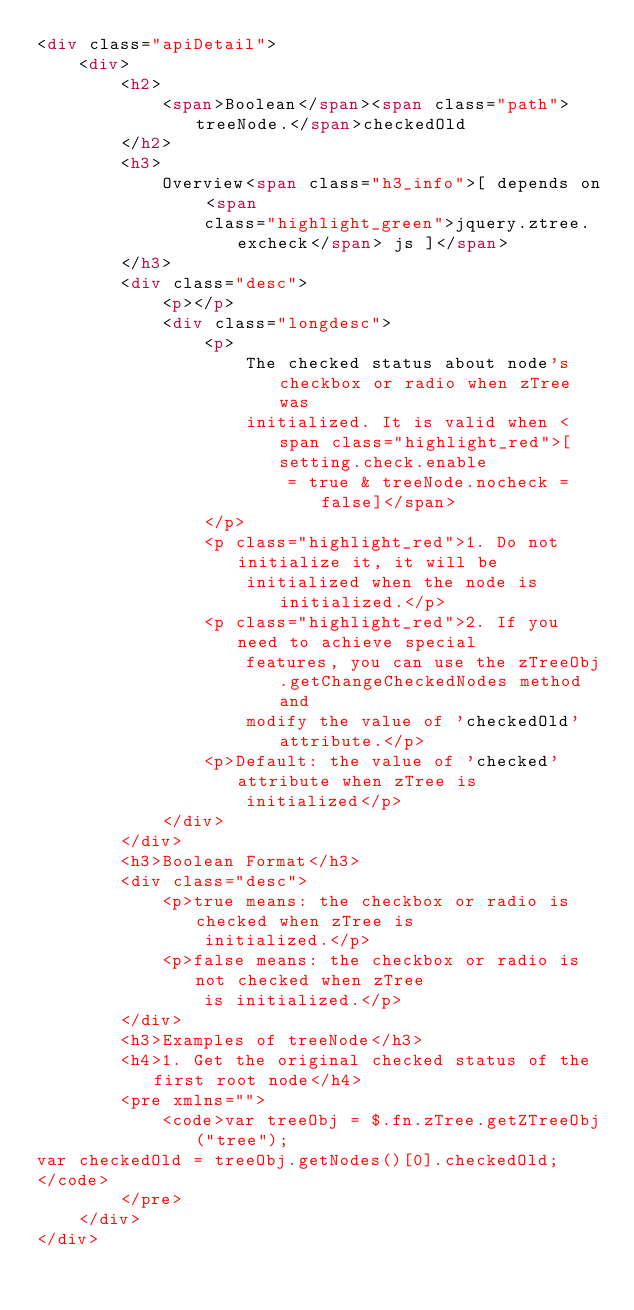Convert code to text. <code><loc_0><loc_0><loc_500><loc_500><_HTML_><div class="apiDetail">
	<div>
		<h2>
			<span>Boolean</span><span class="path">treeNode.</span>checkedOld
		</h2>
		<h3>
			Overview<span class="h3_info">[ depends on <span
				class="highlight_green">jquery.ztree.excheck</span> js ]</span>
		</h3>
		<div class="desc">
			<p></p>
			<div class="longdesc">
				<p>
					The checked status about node's checkbox or radio when zTree was
					initialized. It is valid when <span class="highlight_red">[setting.check.enable
						= true & treeNode.nocheck = false]</span>
				</p>
				<p class="highlight_red">1. Do not initialize it, it will be
					initialized when the node is initialized.</p>
				<p class="highlight_red">2. If you need to achieve special
					features, you can use the zTreeObj.getChangeCheckedNodes method and
					modify the value of 'checkedOld' attribute.</p>
				<p>Default: the value of 'checked' attribute when zTree is
					initialized</p>
			</div>
		</div>
		<h3>Boolean Format</h3>
		<div class="desc">
			<p>true means: the checkbox or radio is checked when zTree is
				initialized.</p>
			<p>false means: the checkbox or radio is not checked when zTree
				is initialized.</p>
		</div>
		<h3>Examples of treeNode</h3>
		<h4>1. Get the original checked status of the first root node</h4>
		<pre xmlns="">
			<code>var treeObj = $.fn.zTree.getZTreeObj("tree");
var checkedOld = treeObj.getNodes()[0].checkedOld;
</code>
		</pre>
	</div>
</div></code> 